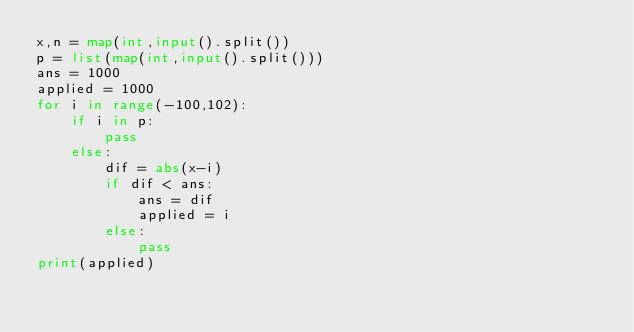Convert code to text. <code><loc_0><loc_0><loc_500><loc_500><_Python_>x,n = map(int,input().split())
p = list(map(int,input().split()))
ans = 1000
applied = 1000
for i in range(-100,102):
    if i in p:
        pass
    else:
        dif = abs(x-i)
        if dif < ans:
            ans = dif
            applied = i
        else:
            pass
print(applied)</code> 